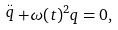<formula> <loc_0><loc_0><loc_500><loc_500>\stackrel { . . } { q } + \omega ( t ) ^ { 2 } q = 0 ,</formula> 